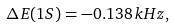<formula> <loc_0><loc_0><loc_500><loc_500>\Delta E ( 1 S ) = - 0 . 1 3 8 \, k H z ,</formula> 